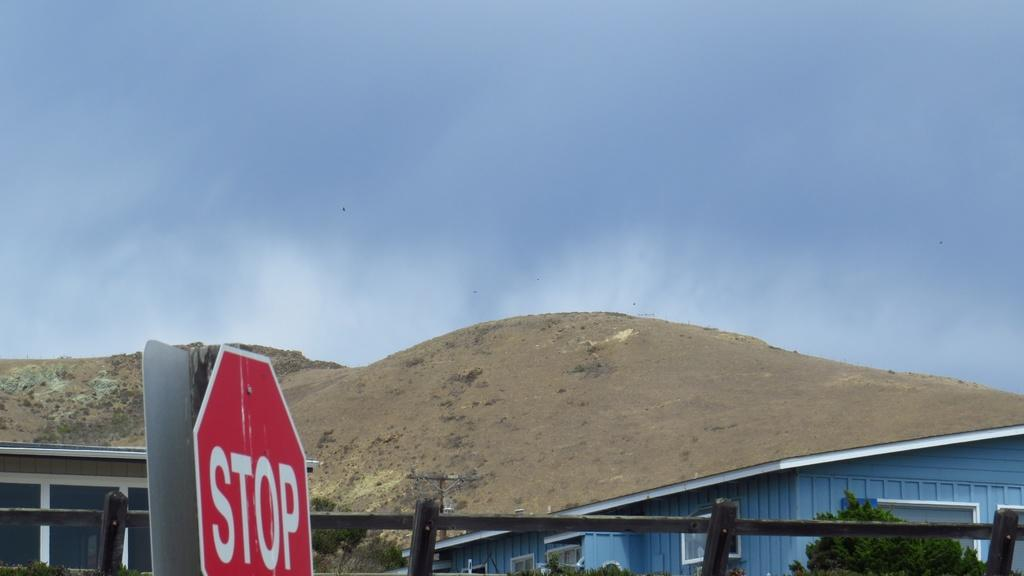<image>
Create a compact narrative representing the image presented. A view of a mountain next to a house and a stop sign is on the side of the road. 